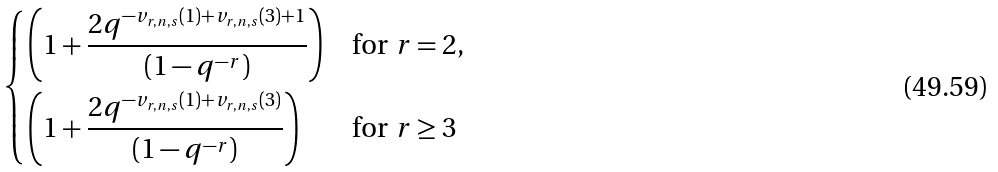Convert formula to latex. <formula><loc_0><loc_0><loc_500><loc_500>\begin{dcases} \left ( 1 + \frac { 2 q ^ { - v _ { r , n , s } ( 1 ) + v _ { r , n , s } ( 3 ) + 1 } } { ( 1 - q ^ { - r } ) } \right ) & \text {for $r =2$} , \\ \left ( 1 + \frac { 2 q ^ { - v _ { r , n , s } ( 1 ) + v _ { r , n , s } ( 3 ) } } { ( 1 - q ^ { - r } ) } \right ) & \text {for $r \geq 3$} \end{dcases}</formula> 